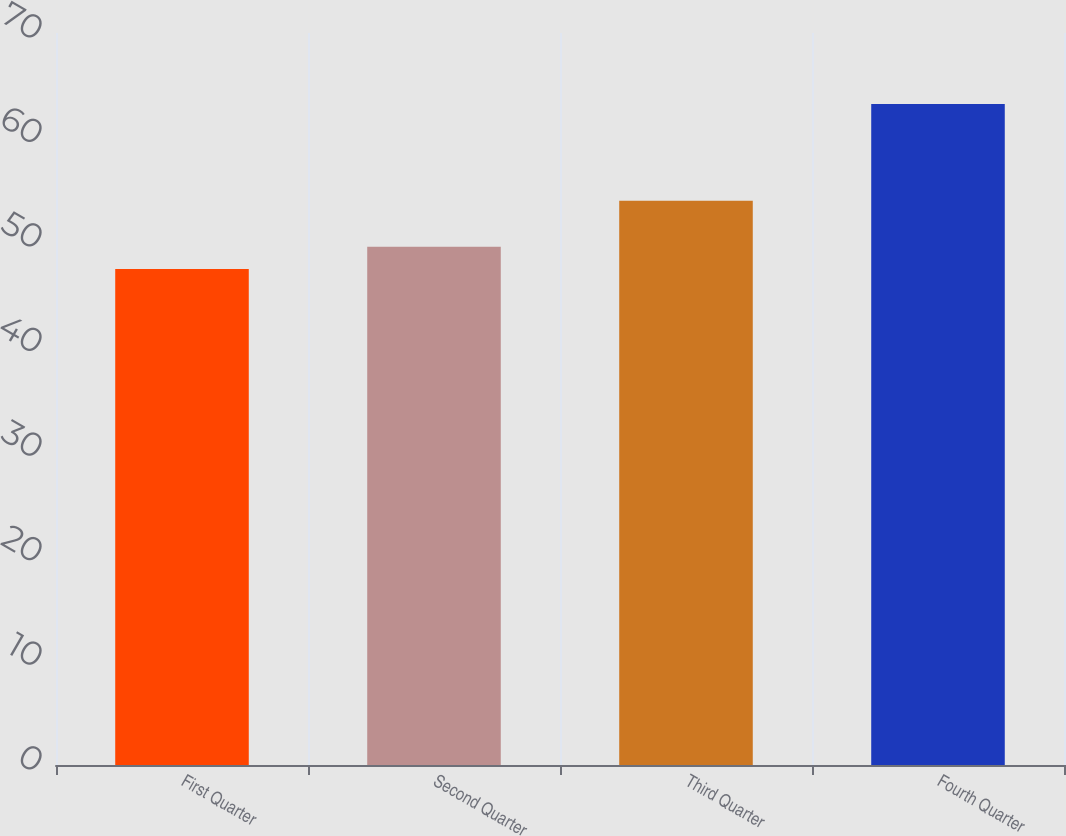Convert chart. <chart><loc_0><loc_0><loc_500><loc_500><bar_chart><fcel>First Quarter<fcel>Second Quarter<fcel>Third Quarter<fcel>Fourth Quarter<nl><fcel>47.43<fcel>49.55<fcel>53.95<fcel>63.21<nl></chart> 